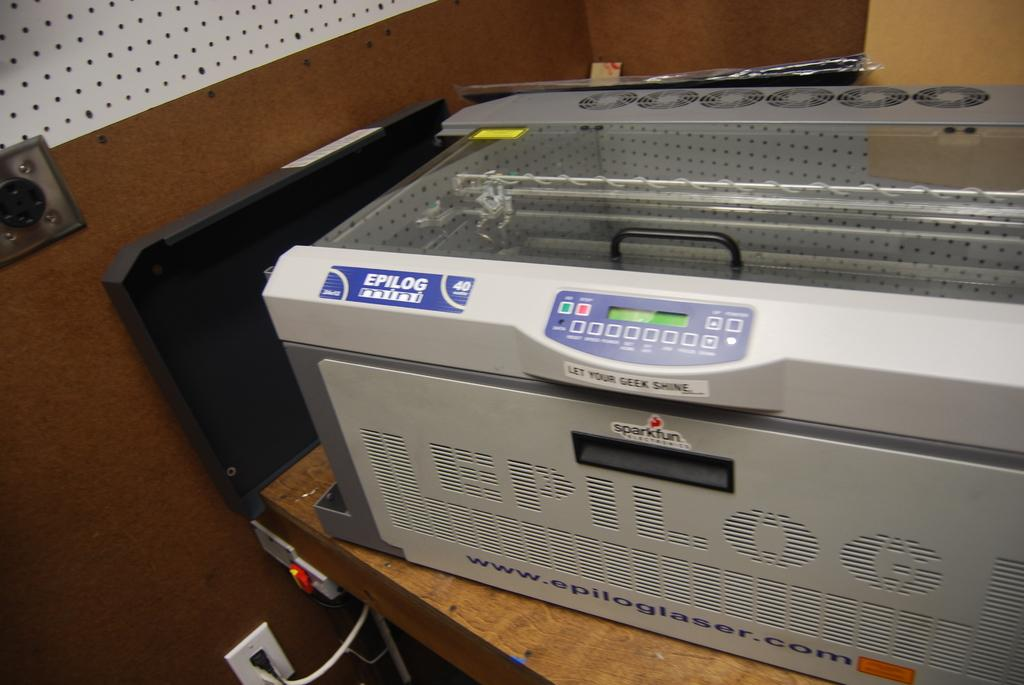<image>
Offer a succinct explanation of the picture presented. Large boxy printer with a blue label that says Epilog. 